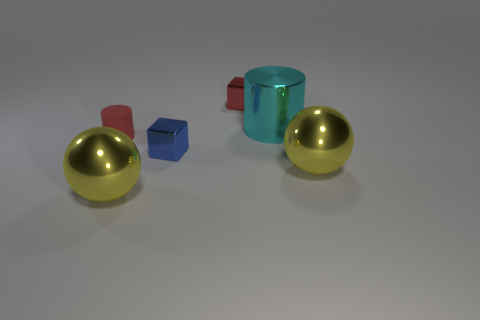Add 3 tiny purple metallic cylinders. How many objects exist? 9 Subtract all spheres. How many objects are left? 4 Add 2 large cyan things. How many large cyan things exist? 3 Subtract 0 yellow cubes. How many objects are left? 6 Subtract all purple spheres. Subtract all red things. How many objects are left? 4 Add 2 small red blocks. How many small red blocks are left? 3 